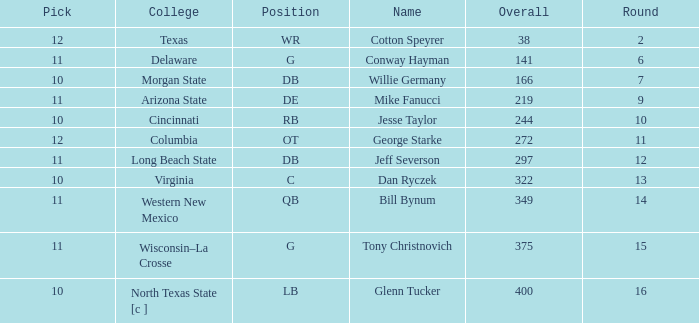What is the lowest round for an overall pick of 349 with a pick number in the round over 11? None. Help me parse the entirety of this table. {'header': ['Pick', 'College', 'Position', 'Name', 'Overall', 'Round'], 'rows': [['12', 'Texas', 'WR', 'Cotton Speyrer', '38', '2'], ['11', 'Delaware', 'G', 'Conway Hayman', '141', '6'], ['10', 'Morgan State', 'DB', 'Willie Germany', '166', '7'], ['11', 'Arizona State', 'DE', 'Mike Fanucci', '219', '9'], ['10', 'Cincinnati', 'RB', 'Jesse Taylor', '244', '10'], ['12', 'Columbia', 'OT', 'George Starke', '272', '11'], ['11', 'Long Beach State', 'DB', 'Jeff Severson', '297', '12'], ['10', 'Virginia', 'C', 'Dan Ryczek', '322', '13'], ['11', 'Western New Mexico', 'QB', 'Bill Bynum', '349', '14'], ['11', 'Wisconsin–La Crosse', 'G', 'Tony Christnovich', '375', '15'], ['10', 'North Texas State [c ]', 'LB', 'Glenn Tucker', '400', '16']]} 